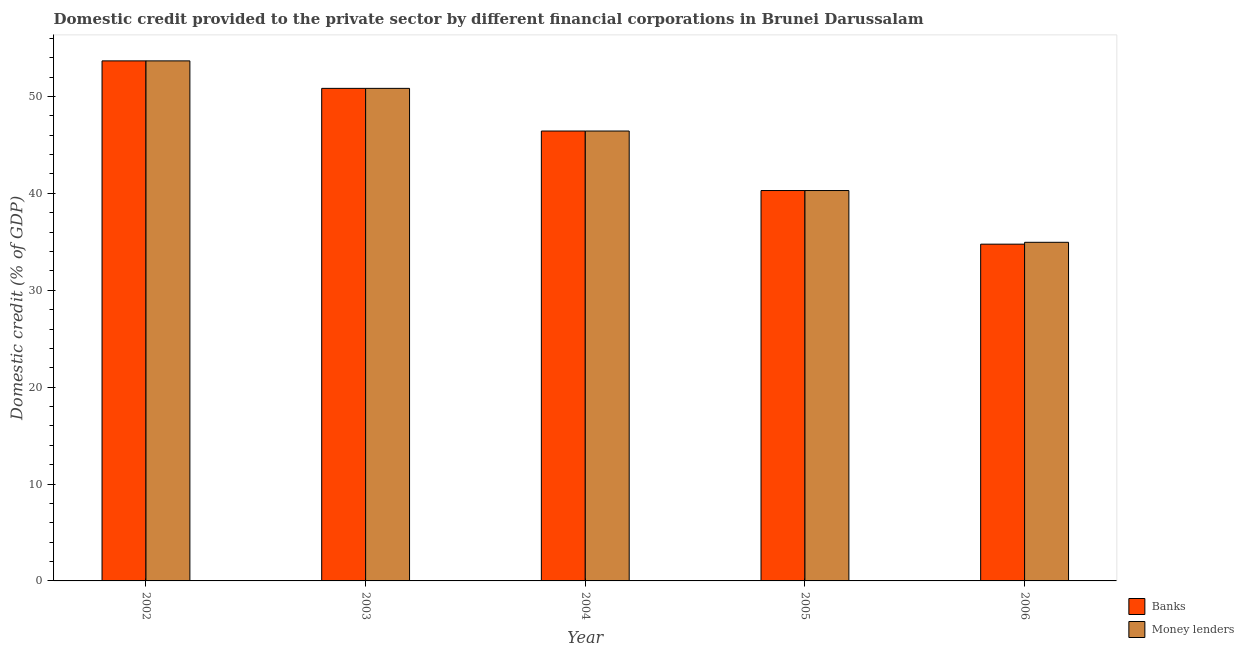How many different coloured bars are there?
Give a very brief answer. 2. Are the number of bars per tick equal to the number of legend labels?
Give a very brief answer. Yes. How many bars are there on the 3rd tick from the left?
Provide a short and direct response. 2. What is the label of the 2nd group of bars from the left?
Give a very brief answer. 2003. In how many cases, is the number of bars for a given year not equal to the number of legend labels?
Offer a very short reply. 0. What is the domestic credit provided by money lenders in 2003?
Provide a short and direct response. 50.84. Across all years, what is the maximum domestic credit provided by banks?
Provide a short and direct response. 53.68. Across all years, what is the minimum domestic credit provided by money lenders?
Provide a succinct answer. 34.95. What is the total domestic credit provided by money lenders in the graph?
Make the answer very short. 226.19. What is the difference between the domestic credit provided by banks in 2002 and that in 2003?
Make the answer very short. 2.84. What is the difference between the domestic credit provided by banks in 2005 and the domestic credit provided by money lenders in 2004?
Provide a succinct answer. -6.14. What is the average domestic credit provided by money lenders per year?
Your answer should be very brief. 45.24. In the year 2005, what is the difference between the domestic credit provided by money lenders and domestic credit provided by banks?
Keep it short and to the point. 0. What is the ratio of the domestic credit provided by money lenders in 2002 to that in 2005?
Your answer should be very brief. 1.33. Is the domestic credit provided by banks in 2002 less than that in 2005?
Provide a short and direct response. No. Is the difference between the domestic credit provided by money lenders in 2005 and 2006 greater than the difference between the domestic credit provided by banks in 2005 and 2006?
Offer a terse response. No. What is the difference between the highest and the second highest domestic credit provided by money lenders?
Provide a succinct answer. 2.84. What is the difference between the highest and the lowest domestic credit provided by money lenders?
Ensure brevity in your answer.  18.73. In how many years, is the domestic credit provided by money lenders greater than the average domestic credit provided by money lenders taken over all years?
Offer a terse response. 3. What does the 1st bar from the left in 2003 represents?
Ensure brevity in your answer.  Banks. What does the 1st bar from the right in 2003 represents?
Provide a succinct answer. Money lenders. How many years are there in the graph?
Ensure brevity in your answer.  5. Are the values on the major ticks of Y-axis written in scientific E-notation?
Your response must be concise. No. Does the graph contain any zero values?
Provide a short and direct response. No. Where does the legend appear in the graph?
Your answer should be very brief. Bottom right. How many legend labels are there?
Provide a short and direct response. 2. How are the legend labels stacked?
Give a very brief answer. Vertical. What is the title of the graph?
Your answer should be compact. Domestic credit provided to the private sector by different financial corporations in Brunei Darussalam. Does "Exports" appear as one of the legend labels in the graph?
Offer a very short reply. No. What is the label or title of the X-axis?
Offer a terse response. Year. What is the label or title of the Y-axis?
Offer a terse response. Domestic credit (% of GDP). What is the Domestic credit (% of GDP) of Banks in 2002?
Ensure brevity in your answer.  53.68. What is the Domestic credit (% of GDP) in Money lenders in 2002?
Provide a succinct answer. 53.68. What is the Domestic credit (% of GDP) in Banks in 2003?
Make the answer very short. 50.84. What is the Domestic credit (% of GDP) in Money lenders in 2003?
Your response must be concise. 50.84. What is the Domestic credit (% of GDP) in Banks in 2004?
Make the answer very short. 46.44. What is the Domestic credit (% of GDP) in Money lenders in 2004?
Provide a short and direct response. 46.44. What is the Domestic credit (% of GDP) in Banks in 2005?
Provide a succinct answer. 40.29. What is the Domestic credit (% of GDP) in Money lenders in 2005?
Provide a short and direct response. 40.29. What is the Domestic credit (% of GDP) of Banks in 2006?
Provide a succinct answer. 34.76. What is the Domestic credit (% of GDP) in Money lenders in 2006?
Offer a very short reply. 34.95. Across all years, what is the maximum Domestic credit (% of GDP) of Banks?
Give a very brief answer. 53.68. Across all years, what is the maximum Domestic credit (% of GDP) of Money lenders?
Provide a succinct answer. 53.68. Across all years, what is the minimum Domestic credit (% of GDP) of Banks?
Your answer should be very brief. 34.76. Across all years, what is the minimum Domestic credit (% of GDP) in Money lenders?
Ensure brevity in your answer.  34.95. What is the total Domestic credit (% of GDP) of Banks in the graph?
Keep it short and to the point. 226. What is the total Domestic credit (% of GDP) of Money lenders in the graph?
Provide a short and direct response. 226.19. What is the difference between the Domestic credit (% of GDP) of Banks in 2002 and that in 2003?
Your answer should be compact. 2.84. What is the difference between the Domestic credit (% of GDP) of Money lenders in 2002 and that in 2003?
Offer a terse response. 2.84. What is the difference between the Domestic credit (% of GDP) in Banks in 2002 and that in 2004?
Keep it short and to the point. 7.24. What is the difference between the Domestic credit (% of GDP) in Money lenders in 2002 and that in 2004?
Your answer should be compact. 7.24. What is the difference between the Domestic credit (% of GDP) of Banks in 2002 and that in 2005?
Make the answer very short. 13.38. What is the difference between the Domestic credit (% of GDP) in Money lenders in 2002 and that in 2005?
Make the answer very short. 13.38. What is the difference between the Domestic credit (% of GDP) in Banks in 2002 and that in 2006?
Provide a succinct answer. 18.92. What is the difference between the Domestic credit (% of GDP) of Money lenders in 2002 and that in 2006?
Offer a very short reply. 18.73. What is the difference between the Domestic credit (% of GDP) in Banks in 2003 and that in 2004?
Offer a terse response. 4.4. What is the difference between the Domestic credit (% of GDP) of Money lenders in 2003 and that in 2004?
Make the answer very short. 4.4. What is the difference between the Domestic credit (% of GDP) in Banks in 2003 and that in 2005?
Your response must be concise. 10.55. What is the difference between the Domestic credit (% of GDP) in Money lenders in 2003 and that in 2005?
Your answer should be compact. 10.55. What is the difference between the Domestic credit (% of GDP) of Banks in 2003 and that in 2006?
Make the answer very short. 16.08. What is the difference between the Domestic credit (% of GDP) in Money lenders in 2003 and that in 2006?
Keep it short and to the point. 15.89. What is the difference between the Domestic credit (% of GDP) in Banks in 2004 and that in 2005?
Your answer should be compact. 6.14. What is the difference between the Domestic credit (% of GDP) of Money lenders in 2004 and that in 2005?
Provide a short and direct response. 6.14. What is the difference between the Domestic credit (% of GDP) in Banks in 2004 and that in 2006?
Ensure brevity in your answer.  11.68. What is the difference between the Domestic credit (% of GDP) of Money lenders in 2004 and that in 2006?
Offer a terse response. 11.49. What is the difference between the Domestic credit (% of GDP) of Banks in 2005 and that in 2006?
Provide a short and direct response. 5.53. What is the difference between the Domestic credit (% of GDP) in Money lenders in 2005 and that in 2006?
Offer a very short reply. 5.34. What is the difference between the Domestic credit (% of GDP) in Banks in 2002 and the Domestic credit (% of GDP) in Money lenders in 2003?
Make the answer very short. 2.84. What is the difference between the Domestic credit (% of GDP) of Banks in 2002 and the Domestic credit (% of GDP) of Money lenders in 2004?
Your answer should be very brief. 7.24. What is the difference between the Domestic credit (% of GDP) of Banks in 2002 and the Domestic credit (% of GDP) of Money lenders in 2005?
Make the answer very short. 13.38. What is the difference between the Domestic credit (% of GDP) in Banks in 2002 and the Domestic credit (% of GDP) in Money lenders in 2006?
Your response must be concise. 18.73. What is the difference between the Domestic credit (% of GDP) in Banks in 2003 and the Domestic credit (% of GDP) in Money lenders in 2004?
Offer a terse response. 4.4. What is the difference between the Domestic credit (% of GDP) in Banks in 2003 and the Domestic credit (% of GDP) in Money lenders in 2005?
Offer a very short reply. 10.55. What is the difference between the Domestic credit (% of GDP) of Banks in 2003 and the Domestic credit (% of GDP) of Money lenders in 2006?
Provide a short and direct response. 15.89. What is the difference between the Domestic credit (% of GDP) of Banks in 2004 and the Domestic credit (% of GDP) of Money lenders in 2005?
Provide a short and direct response. 6.14. What is the difference between the Domestic credit (% of GDP) in Banks in 2004 and the Domestic credit (% of GDP) in Money lenders in 2006?
Provide a short and direct response. 11.49. What is the difference between the Domestic credit (% of GDP) of Banks in 2005 and the Domestic credit (% of GDP) of Money lenders in 2006?
Make the answer very short. 5.34. What is the average Domestic credit (% of GDP) of Banks per year?
Your response must be concise. 45.2. What is the average Domestic credit (% of GDP) of Money lenders per year?
Offer a terse response. 45.24. In the year 2004, what is the difference between the Domestic credit (% of GDP) of Banks and Domestic credit (% of GDP) of Money lenders?
Your response must be concise. 0. In the year 2005, what is the difference between the Domestic credit (% of GDP) in Banks and Domestic credit (% of GDP) in Money lenders?
Your response must be concise. 0. In the year 2006, what is the difference between the Domestic credit (% of GDP) of Banks and Domestic credit (% of GDP) of Money lenders?
Your answer should be compact. -0.19. What is the ratio of the Domestic credit (% of GDP) of Banks in 2002 to that in 2003?
Ensure brevity in your answer.  1.06. What is the ratio of the Domestic credit (% of GDP) in Money lenders in 2002 to that in 2003?
Your answer should be very brief. 1.06. What is the ratio of the Domestic credit (% of GDP) in Banks in 2002 to that in 2004?
Provide a short and direct response. 1.16. What is the ratio of the Domestic credit (% of GDP) in Money lenders in 2002 to that in 2004?
Provide a short and direct response. 1.16. What is the ratio of the Domestic credit (% of GDP) in Banks in 2002 to that in 2005?
Provide a short and direct response. 1.33. What is the ratio of the Domestic credit (% of GDP) in Money lenders in 2002 to that in 2005?
Make the answer very short. 1.33. What is the ratio of the Domestic credit (% of GDP) of Banks in 2002 to that in 2006?
Your answer should be compact. 1.54. What is the ratio of the Domestic credit (% of GDP) in Money lenders in 2002 to that in 2006?
Make the answer very short. 1.54. What is the ratio of the Domestic credit (% of GDP) in Banks in 2003 to that in 2004?
Provide a succinct answer. 1.09. What is the ratio of the Domestic credit (% of GDP) of Money lenders in 2003 to that in 2004?
Ensure brevity in your answer.  1.09. What is the ratio of the Domestic credit (% of GDP) of Banks in 2003 to that in 2005?
Make the answer very short. 1.26. What is the ratio of the Domestic credit (% of GDP) of Money lenders in 2003 to that in 2005?
Your answer should be very brief. 1.26. What is the ratio of the Domestic credit (% of GDP) in Banks in 2003 to that in 2006?
Ensure brevity in your answer.  1.46. What is the ratio of the Domestic credit (% of GDP) in Money lenders in 2003 to that in 2006?
Your answer should be compact. 1.45. What is the ratio of the Domestic credit (% of GDP) in Banks in 2004 to that in 2005?
Provide a succinct answer. 1.15. What is the ratio of the Domestic credit (% of GDP) in Money lenders in 2004 to that in 2005?
Your answer should be compact. 1.15. What is the ratio of the Domestic credit (% of GDP) in Banks in 2004 to that in 2006?
Ensure brevity in your answer.  1.34. What is the ratio of the Domestic credit (% of GDP) of Money lenders in 2004 to that in 2006?
Provide a short and direct response. 1.33. What is the ratio of the Domestic credit (% of GDP) in Banks in 2005 to that in 2006?
Your answer should be very brief. 1.16. What is the ratio of the Domestic credit (% of GDP) of Money lenders in 2005 to that in 2006?
Keep it short and to the point. 1.15. What is the difference between the highest and the second highest Domestic credit (% of GDP) of Banks?
Offer a very short reply. 2.84. What is the difference between the highest and the second highest Domestic credit (% of GDP) in Money lenders?
Make the answer very short. 2.84. What is the difference between the highest and the lowest Domestic credit (% of GDP) of Banks?
Your answer should be compact. 18.92. What is the difference between the highest and the lowest Domestic credit (% of GDP) of Money lenders?
Your answer should be very brief. 18.73. 